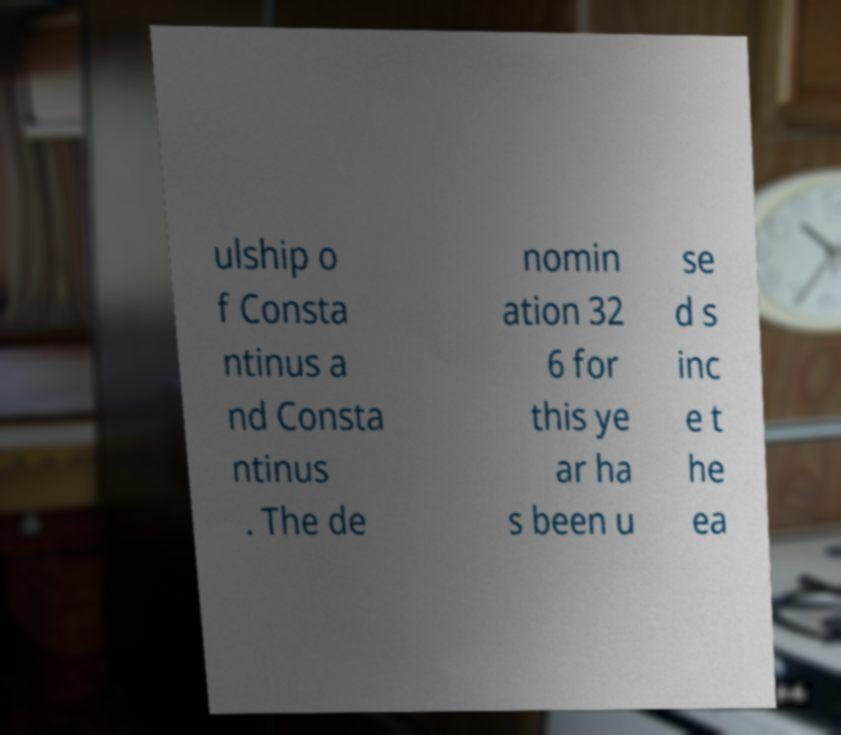Please read and relay the text visible in this image. What does it say? ulship o f Consta ntinus a nd Consta ntinus . The de nomin ation 32 6 for this ye ar ha s been u se d s inc e t he ea 